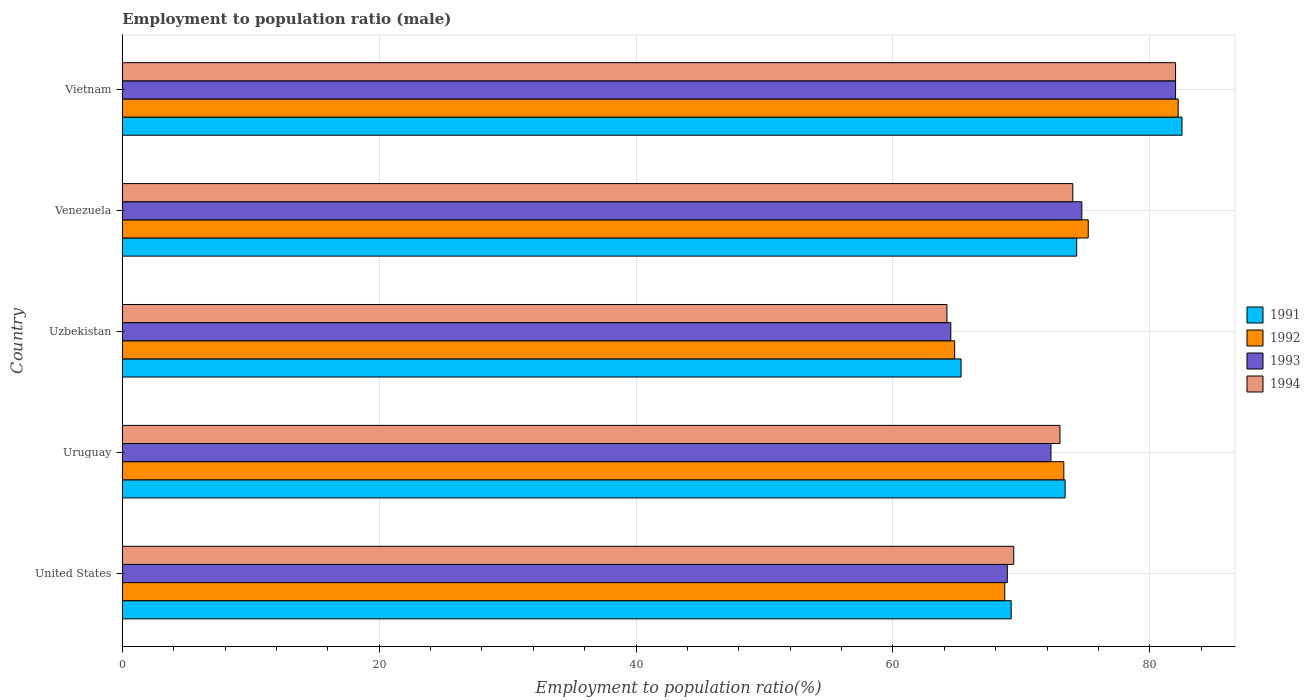Are the number of bars on each tick of the Y-axis equal?
Offer a very short reply. Yes. What is the label of the 5th group of bars from the top?
Make the answer very short. United States. In how many cases, is the number of bars for a given country not equal to the number of legend labels?
Provide a short and direct response. 0. What is the employment to population ratio in 1993 in Venezuela?
Your answer should be compact. 74.7. Across all countries, what is the minimum employment to population ratio in 1994?
Ensure brevity in your answer.  64.2. In which country was the employment to population ratio in 1994 maximum?
Make the answer very short. Vietnam. In which country was the employment to population ratio in 1991 minimum?
Offer a very short reply. Uzbekistan. What is the total employment to population ratio in 1993 in the graph?
Your response must be concise. 362.4. What is the difference between the employment to population ratio in 1992 in Uruguay and that in Vietnam?
Your response must be concise. -8.9. What is the difference between the employment to population ratio in 1993 in Vietnam and the employment to population ratio in 1992 in Uruguay?
Make the answer very short. 8.7. What is the average employment to population ratio in 1991 per country?
Make the answer very short. 72.94. What is the difference between the employment to population ratio in 1991 and employment to population ratio in 1994 in Uzbekistan?
Your response must be concise. 1.1. In how many countries, is the employment to population ratio in 1994 greater than 64 %?
Your answer should be compact. 5. What is the ratio of the employment to population ratio in 1992 in Uzbekistan to that in Vietnam?
Provide a short and direct response. 0.79. Is the difference between the employment to population ratio in 1991 in Uruguay and Venezuela greater than the difference between the employment to population ratio in 1994 in Uruguay and Venezuela?
Give a very brief answer. Yes. What is the difference between the highest and the second highest employment to population ratio in 1991?
Make the answer very short. 8.2. What is the difference between the highest and the lowest employment to population ratio in 1992?
Ensure brevity in your answer.  17.4. Is the sum of the employment to population ratio in 1993 in Uruguay and Uzbekistan greater than the maximum employment to population ratio in 1994 across all countries?
Provide a succinct answer. Yes. What does the 1st bar from the bottom in Uzbekistan represents?
Give a very brief answer. 1991. Is it the case that in every country, the sum of the employment to population ratio in 1992 and employment to population ratio in 1994 is greater than the employment to population ratio in 1993?
Keep it short and to the point. Yes. Does the graph contain any zero values?
Keep it short and to the point. No. Where does the legend appear in the graph?
Provide a succinct answer. Center right. How many legend labels are there?
Keep it short and to the point. 4. How are the legend labels stacked?
Offer a terse response. Vertical. What is the title of the graph?
Ensure brevity in your answer.  Employment to population ratio (male). Does "1990" appear as one of the legend labels in the graph?
Keep it short and to the point. No. What is the label or title of the X-axis?
Keep it short and to the point. Employment to population ratio(%). What is the label or title of the Y-axis?
Keep it short and to the point. Country. What is the Employment to population ratio(%) of 1991 in United States?
Keep it short and to the point. 69.2. What is the Employment to population ratio(%) of 1992 in United States?
Your answer should be very brief. 68.7. What is the Employment to population ratio(%) in 1993 in United States?
Provide a succinct answer. 68.9. What is the Employment to population ratio(%) of 1994 in United States?
Provide a short and direct response. 69.4. What is the Employment to population ratio(%) of 1991 in Uruguay?
Offer a very short reply. 73.4. What is the Employment to population ratio(%) of 1992 in Uruguay?
Provide a short and direct response. 73.3. What is the Employment to population ratio(%) of 1993 in Uruguay?
Provide a short and direct response. 72.3. What is the Employment to population ratio(%) of 1994 in Uruguay?
Ensure brevity in your answer.  73. What is the Employment to population ratio(%) of 1991 in Uzbekistan?
Ensure brevity in your answer.  65.3. What is the Employment to population ratio(%) in 1992 in Uzbekistan?
Make the answer very short. 64.8. What is the Employment to population ratio(%) in 1993 in Uzbekistan?
Offer a terse response. 64.5. What is the Employment to population ratio(%) in 1994 in Uzbekistan?
Provide a succinct answer. 64.2. What is the Employment to population ratio(%) of 1991 in Venezuela?
Your answer should be compact. 74.3. What is the Employment to population ratio(%) in 1992 in Venezuela?
Your answer should be very brief. 75.2. What is the Employment to population ratio(%) in 1993 in Venezuela?
Ensure brevity in your answer.  74.7. What is the Employment to population ratio(%) in 1994 in Venezuela?
Offer a very short reply. 74. What is the Employment to population ratio(%) in 1991 in Vietnam?
Provide a short and direct response. 82.5. What is the Employment to population ratio(%) in 1992 in Vietnam?
Your answer should be very brief. 82.2. What is the Employment to population ratio(%) of 1993 in Vietnam?
Offer a terse response. 82. Across all countries, what is the maximum Employment to population ratio(%) of 1991?
Offer a terse response. 82.5. Across all countries, what is the maximum Employment to population ratio(%) of 1992?
Give a very brief answer. 82.2. Across all countries, what is the minimum Employment to population ratio(%) in 1991?
Make the answer very short. 65.3. Across all countries, what is the minimum Employment to population ratio(%) of 1992?
Offer a terse response. 64.8. Across all countries, what is the minimum Employment to population ratio(%) in 1993?
Provide a succinct answer. 64.5. Across all countries, what is the minimum Employment to population ratio(%) of 1994?
Keep it short and to the point. 64.2. What is the total Employment to population ratio(%) of 1991 in the graph?
Your answer should be compact. 364.7. What is the total Employment to population ratio(%) of 1992 in the graph?
Ensure brevity in your answer.  364.2. What is the total Employment to population ratio(%) of 1993 in the graph?
Keep it short and to the point. 362.4. What is the total Employment to population ratio(%) in 1994 in the graph?
Provide a short and direct response. 362.6. What is the difference between the Employment to population ratio(%) of 1992 in United States and that in Uruguay?
Offer a very short reply. -4.6. What is the difference between the Employment to population ratio(%) of 1993 in United States and that in Uruguay?
Offer a terse response. -3.4. What is the difference between the Employment to population ratio(%) of 1994 in United States and that in Uruguay?
Your answer should be very brief. -3.6. What is the difference between the Employment to population ratio(%) in 1991 in United States and that in Uzbekistan?
Provide a short and direct response. 3.9. What is the difference between the Employment to population ratio(%) of 1992 in United States and that in Uzbekistan?
Keep it short and to the point. 3.9. What is the difference between the Employment to population ratio(%) in 1991 in United States and that in Venezuela?
Offer a very short reply. -5.1. What is the difference between the Employment to population ratio(%) in 1994 in United States and that in Venezuela?
Your answer should be very brief. -4.6. What is the difference between the Employment to population ratio(%) in 1991 in United States and that in Vietnam?
Provide a succinct answer. -13.3. What is the difference between the Employment to population ratio(%) in 1992 in United States and that in Vietnam?
Provide a short and direct response. -13.5. What is the difference between the Employment to population ratio(%) in 1994 in United States and that in Vietnam?
Give a very brief answer. -12.6. What is the difference between the Employment to population ratio(%) of 1991 in Uruguay and that in Uzbekistan?
Give a very brief answer. 8.1. What is the difference between the Employment to population ratio(%) in 1994 in Uruguay and that in Uzbekistan?
Keep it short and to the point. 8.8. What is the difference between the Employment to population ratio(%) of 1991 in Uruguay and that in Vietnam?
Offer a very short reply. -9.1. What is the difference between the Employment to population ratio(%) in 1992 in Uruguay and that in Vietnam?
Offer a terse response. -8.9. What is the difference between the Employment to population ratio(%) of 1994 in Uruguay and that in Vietnam?
Give a very brief answer. -9. What is the difference between the Employment to population ratio(%) of 1994 in Uzbekistan and that in Venezuela?
Offer a very short reply. -9.8. What is the difference between the Employment to population ratio(%) in 1991 in Uzbekistan and that in Vietnam?
Your answer should be very brief. -17.2. What is the difference between the Employment to population ratio(%) in 1992 in Uzbekistan and that in Vietnam?
Offer a terse response. -17.4. What is the difference between the Employment to population ratio(%) in 1993 in Uzbekistan and that in Vietnam?
Provide a succinct answer. -17.5. What is the difference between the Employment to population ratio(%) of 1994 in Uzbekistan and that in Vietnam?
Offer a very short reply. -17.8. What is the difference between the Employment to population ratio(%) of 1992 in Venezuela and that in Vietnam?
Offer a terse response. -7. What is the difference between the Employment to population ratio(%) in 1993 in Venezuela and that in Vietnam?
Provide a short and direct response. -7.3. What is the difference between the Employment to population ratio(%) of 1994 in Venezuela and that in Vietnam?
Make the answer very short. -8. What is the difference between the Employment to population ratio(%) in 1991 in United States and the Employment to population ratio(%) in 1994 in Uruguay?
Give a very brief answer. -3.8. What is the difference between the Employment to population ratio(%) in 1993 in United States and the Employment to population ratio(%) in 1994 in Uruguay?
Your response must be concise. -4.1. What is the difference between the Employment to population ratio(%) of 1991 in United States and the Employment to population ratio(%) of 1992 in Uzbekistan?
Keep it short and to the point. 4.4. What is the difference between the Employment to population ratio(%) of 1991 in United States and the Employment to population ratio(%) of 1994 in Uzbekistan?
Your answer should be very brief. 5. What is the difference between the Employment to population ratio(%) in 1991 in United States and the Employment to population ratio(%) in 1994 in Venezuela?
Offer a very short reply. -4.8. What is the difference between the Employment to population ratio(%) of 1992 in United States and the Employment to population ratio(%) of 1994 in Venezuela?
Provide a succinct answer. -5.3. What is the difference between the Employment to population ratio(%) in 1993 in United States and the Employment to population ratio(%) in 1994 in Venezuela?
Keep it short and to the point. -5.1. What is the difference between the Employment to population ratio(%) in 1991 in United States and the Employment to population ratio(%) in 1992 in Vietnam?
Keep it short and to the point. -13. What is the difference between the Employment to population ratio(%) in 1991 in United States and the Employment to population ratio(%) in 1994 in Vietnam?
Give a very brief answer. -12.8. What is the difference between the Employment to population ratio(%) of 1992 in United States and the Employment to population ratio(%) of 1993 in Vietnam?
Make the answer very short. -13.3. What is the difference between the Employment to population ratio(%) of 1991 in Uruguay and the Employment to population ratio(%) of 1993 in Uzbekistan?
Your answer should be compact. 8.9. What is the difference between the Employment to population ratio(%) of 1991 in Uruguay and the Employment to population ratio(%) of 1994 in Uzbekistan?
Your answer should be very brief. 9.2. What is the difference between the Employment to population ratio(%) of 1992 in Uruguay and the Employment to population ratio(%) of 1993 in Uzbekistan?
Give a very brief answer. 8.8. What is the difference between the Employment to population ratio(%) in 1992 in Uruguay and the Employment to population ratio(%) in 1994 in Uzbekistan?
Offer a terse response. 9.1. What is the difference between the Employment to population ratio(%) in 1993 in Uruguay and the Employment to population ratio(%) in 1994 in Uzbekistan?
Offer a terse response. 8.1. What is the difference between the Employment to population ratio(%) of 1991 in Uruguay and the Employment to population ratio(%) of 1992 in Venezuela?
Offer a terse response. -1.8. What is the difference between the Employment to population ratio(%) in 1991 in Uruguay and the Employment to population ratio(%) in 1993 in Venezuela?
Your answer should be very brief. -1.3. What is the difference between the Employment to population ratio(%) of 1991 in Uruguay and the Employment to population ratio(%) of 1994 in Venezuela?
Offer a terse response. -0.6. What is the difference between the Employment to population ratio(%) in 1992 in Uruguay and the Employment to population ratio(%) in 1993 in Venezuela?
Provide a succinct answer. -1.4. What is the difference between the Employment to population ratio(%) in 1992 in Uruguay and the Employment to population ratio(%) in 1994 in Venezuela?
Provide a short and direct response. -0.7. What is the difference between the Employment to population ratio(%) in 1993 in Uruguay and the Employment to population ratio(%) in 1994 in Venezuela?
Your answer should be very brief. -1.7. What is the difference between the Employment to population ratio(%) of 1991 in Uruguay and the Employment to population ratio(%) of 1992 in Vietnam?
Your answer should be compact. -8.8. What is the difference between the Employment to population ratio(%) of 1991 in Uruguay and the Employment to population ratio(%) of 1994 in Vietnam?
Ensure brevity in your answer.  -8.6. What is the difference between the Employment to population ratio(%) of 1992 in Uruguay and the Employment to population ratio(%) of 1993 in Vietnam?
Provide a short and direct response. -8.7. What is the difference between the Employment to population ratio(%) in 1993 in Uruguay and the Employment to population ratio(%) in 1994 in Vietnam?
Your response must be concise. -9.7. What is the difference between the Employment to population ratio(%) in 1991 in Uzbekistan and the Employment to population ratio(%) in 1993 in Venezuela?
Provide a succinct answer. -9.4. What is the difference between the Employment to population ratio(%) of 1992 in Uzbekistan and the Employment to population ratio(%) of 1993 in Venezuela?
Your response must be concise. -9.9. What is the difference between the Employment to population ratio(%) of 1993 in Uzbekistan and the Employment to population ratio(%) of 1994 in Venezuela?
Provide a short and direct response. -9.5. What is the difference between the Employment to population ratio(%) in 1991 in Uzbekistan and the Employment to population ratio(%) in 1992 in Vietnam?
Offer a terse response. -16.9. What is the difference between the Employment to population ratio(%) in 1991 in Uzbekistan and the Employment to population ratio(%) in 1993 in Vietnam?
Your answer should be very brief. -16.7. What is the difference between the Employment to population ratio(%) in 1991 in Uzbekistan and the Employment to population ratio(%) in 1994 in Vietnam?
Offer a terse response. -16.7. What is the difference between the Employment to population ratio(%) in 1992 in Uzbekistan and the Employment to population ratio(%) in 1993 in Vietnam?
Your answer should be compact. -17.2. What is the difference between the Employment to population ratio(%) in 1992 in Uzbekistan and the Employment to population ratio(%) in 1994 in Vietnam?
Offer a terse response. -17.2. What is the difference between the Employment to population ratio(%) of 1993 in Uzbekistan and the Employment to population ratio(%) of 1994 in Vietnam?
Ensure brevity in your answer.  -17.5. What is the difference between the Employment to population ratio(%) of 1991 in Venezuela and the Employment to population ratio(%) of 1992 in Vietnam?
Offer a terse response. -7.9. What is the difference between the Employment to population ratio(%) in 1991 in Venezuela and the Employment to population ratio(%) in 1994 in Vietnam?
Offer a terse response. -7.7. What is the difference between the Employment to population ratio(%) of 1993 in Venezuela and the Employment to population ratio(%) of 1994 in Vietnam?
Keep it short and to the point. -7.3. What is the average Employment to population ratio(%) in 1991 per country?
Make the answer very short. 72.94. What is the average Employment to population ratio(%) in 1992 per country?
Give a very brief answer. 72.84. What is the average Employment to population ratio(%) in 1993 per country?
Your response must be concise. 72.48. What is the average Employment to population ratio(%) of 1994 per country?
Your answer should be compact. 72.52. What is the difference between the Employment to population ratio(%) of 1992 and Employment to population ratio(%) of 1993 in United States?
Your answer should be very brief. -0.2. What is the difference between the Employment to population ratio(%) of 1992 and Employment to population ratio(%) of 1994 in United States?
Your response must be concise. -0.7. What is the difference between the Employment to population ratio(%) of 1992 and Employment to population ratio(%) of 1993 in Uruguay?
Give a very brief answer. 1. What is the difference between the Employment to population ratio(%) of 1991 and Employment to population ratio(%) of 1994 in Uzbekistan?
Make the answer very short. 1.1. What is the difference between the Employment to population ratio(%) of 1992 and Employment to population ratio(%) of 1994 in Uzbekistan?
Offer a very short reply. 0.6. What is the difference between the Employment to population ratio(%) in 1993 and Employment to population ratio(%) in 1994 in Uzbekistan?
Your answer should be very brief. 0.3. What is the difference between the Employment to population ratio(%) of 1991 and Employment to population ratio(%) of 1992 in Venezuela?
Ensure brevity in your answer.  -0.9. What is the difference between the Employment to population ratio(%) of 1991 and Employment to population ratio(%) of 1994 in Venezuela?
Ensure brevity in your answer.  0.3. What is the difference between the Employment to population ratio(%) of 1992 and Employment to population ratio(%) of 1993 in Venezuela?
Ensure brevity in your answer.  0.5. What is the difference between the Employment to population ratio(%) in 1992 and Employment to population ratio(%) in 1994 in Venezuela?
Make the answer very short. 1.2. What is the difference between the Employment to population ratio(%) in 1991 and Employment to population ratio(%) in 1992 in Vietnam?
Provide a short and direct response. 0.3. What is the difference between the Employment to population ratio(%) in 1991 and Employment to population ratio(%) in 1993 in Vietnam?
Give a very brief answer. 0.5. What is the difference between the Employment to population ratio(%) in 1992 and Employment to population ratio(%) in 1993 in Vietnam?
Provide a short and direct response. 0.2. What is the ratio of the Employment to population ratio(%) of 1991 in United States to that in Uruguay?
Offer a terse response. 0.94. What is the ratio of the Employment to population ratio(%) in 1992 in United States to that in Uruguay?
Offer a very short reply. 0.94. What is the ratio of the Employment to population ratio(%) of 1993 in United States to that in Uruguay?
Your answer should be compact. 0.95. What is the ratio of the Employment to population ratio(%) of 1994 in United States to that in Uruguay?
Give a very brief answer. 0.95. What is the ratio of the Employment to population ratio(%) in 1991 in United States to that in Uzbekistan?
Your response must be concise. 1.06. What is the ratio of the Employment to population ratio(%) in 1992 in United States to that in Uzbekistan?
Ensure brevity in your answer.  1.06. What is the ratio of the Employment to population ratio(%) in 1993 in United States to that in Uzbekistan?
Your response must be concise. 1.07. What is the ratio of the Employment to population ratio(%) of 1994 in United States to that in Uzbekistan?
Offer a terse response. 1.08. What is the ratio of the Employment to population ratio(%) of 1991 in United States to that in Venezuela?
Make the answer very short. 0.93. What is the ratio of the Employment to population ratio(%) of 1992 in United States to that in Venezuela?
Your answer should be compact. 0.91. What is the ratio of the Employment to population ratio(%) of 1993 in United States to that in Venezuela?
Give a very brief answer. 0.92. What is the ratio of the Employment to population ratio(%) in 1994 in United States to that in Venezuela?
Provide a succinct answer. 0.94. What is the ratio of the Employment to population ratio(%) of 1991 in United States to that in Vietnam?
Give a very brief answer. 0.84. What is the ratio of the Employment to population ratio(%) of 1992 in United States to that in Vietnam?
Offer a terse response. 0.84. What is the ratio of the Employment to population ratio(%) of 1993 in United States to that in Vietnam?
Your answer should be compact. 0.84. What is the ratio of the Employment to population ratio(%) of 1994 in United States to that in Vietnam?
Ensure brevity in your answer.  0.85. What is the ratio of the Employment to population ratio(%) of 1991 in Uruguay to that in Uzbekistan?
Make the answer very short. 1.12. What is the ratio of the Employment to population ratio(%) in 1992 in Uruguay to that in Uzbekistan?
Give a very brief answer. 1.13. What is the ratio of the Employment to population ratio(%) in 1993 in Uruguay to that in Uzbekistan?
Offer a terse response. 1.12. What is the ratio of the Employment to population ratio(%) of 1994 in Uruguay to that in Uzbekistan?
Give a very brief answer. 1.14. What is the ratio of the Employment to population ratio(%) in 1991 in Uruguay to that in Venezuela?
Your response must be concise. 0.99. What is the ratio of the Employment to population ratio(%) of 1992 in Uruguay to that in Venezuela?
Your answer should be very brief. 0.97. What is the ratio of the Employment to population ratio(%) in 1993 in Uruguay to that in Venezuela?
Keep it short and to the point. 0.97. What is the ratio of the Employment to population ratio(%) in 1994 in Uruguay to that in Venezuela?
Ensure brevity in your answer.  0.99. What is the ratio of the Employment to population ratio(%) of 1991 in Uruguay to that in Vietnam?
Make the answer very short. 0.89. What is the ratio of the Employment to population ratio(%) in 1992 in Uruguay to that in Vietnam?
Provide a short and direct response. 0.89. What is the ratio of the Employment to population ratio(%) of 1993 in Uruguay to that in Vietnam?
Offer a terse response. 0.88. What is the ratio of the Employment to population ratio(%) in 1994 in Uruguay to that in Vietnam?
Offer a very short reply. 0.89. What is the ratio of the Employment to population ratio(%) in 1991 in Uzbekistan to that in Venezuela?
Ensure brevity in your answer.  0.88. What is the ratio of the Employment to population ratio(%) in 1992 in Uzbekistan to that in Venezuela?
Keep it short and to the point. 0.86. What is the ratio of the Employment to population ratio(%) in 1993 in Uzbekistan to that in Venezuela?
Your answer should be very brief. 0.86. What is the ratio of the Employment to population ratio(%) of 1994 in Uzbekistan to that in Venezuela?
Offer a very short reply. 0.87. What is the ratio of the Employment to population ratio(%) of 1991 in Uzbekistan to that in Vietnam?
Your answer should be compact. 0.79. What is the ratio of the Employment to population ratio(%) of 1992 in Uzbekistan to that in Vietnam?
Your response must be concise. 0.79. What is the ratio of the Employment to population ratio(%) of 1993 in Uzbekistan to that in Vietnam?
Offer a terse response. 0.79. What is the ratio of the Employment to population ratio(%) of 1994 in Uzbekistan to that in Vietnam?
Give a very brief answer. 0.78. What is the ratio of the Employment to population ratio(%) in 1991 in Venezuela to that in Vietnam?
Offer a very short reply. 0.9. What is the ratio of the Employment to population ratio(%) of 1992 in Venezuela to that in Vietnam?
Your answer should be very brief. 0.91. What is the ratio of the Employment to population ratio(%) in 1993 in Venezuela to that in Vietnam?
Provide a short and direct response. 0.91. What is the ratio of the Employment to population ratio(%) in 1994 in Venezuela to that in Vietnam?
Ensure brevity in your answer.  0.9. What is the difference between the highest and the second highest Employment to population ratio(%) of 1991?
Your response must be concise. 8.2. What is the difference between the highest and the second highest Employment to population ratio(%) of 1992?
Keep it short and to the point. 7. What is the difference between the highest and the lowest Employment to population ratio(%) in 1991?
Offer a very short reply. 17.2. What is the difference between the highest and the lowest Employment to population ratio(%) of 1993?
Offer a terse response. 17.5. 